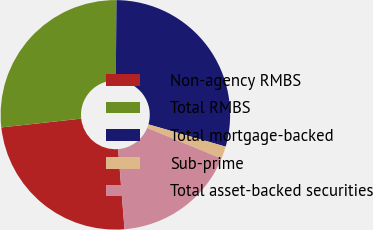Convert chart. <chart><loc_0><loc_0><loc_500><loc_500><pie_chart><fcel>Non-agency RMBS<fcel>Total RMBS<fcel>Total mortgage-backed<fcel>Sub-prime<fcel>Total asset-backed securities<nl><fcel>24.52%<fcel>26.91%<fcel>29.31%<fcel>1.75%<fcel>17.51%<nl></chart> 